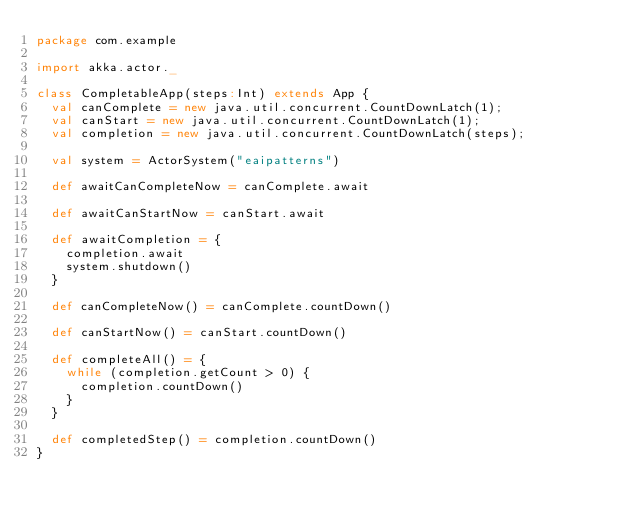<code> <loc_0><loc_0><loc_500><loc_500><_Scala_>package com.example

import akka.actor._

class CompletableApp(steps:Int) extends App {
  val canComplete = new java.util.concurrent.CountDownLatch(1);
  val canStart = new java.util.concurrent.CountDownLatch(1);
  val completion = new java.util.concurrent.CountDownLatch(steps);

  val system = ActorSystem("eaipatterns")

  def awaitCanCompleteNow = canComplete.await

  def awaitCanStartNow = canStart.await

  def awaitCompletion = {
    completion.await
    system.shutdown()
  }

  def canCompleteNow() = canComplete.countDown()

  def canStartNow() = canStart.countDown()

  def completeAll() = {
    while (completion.getCount > 0) {
      completion.countDown()
    }
  }

  def completedStep() = completion.countDown()
}
</code> 